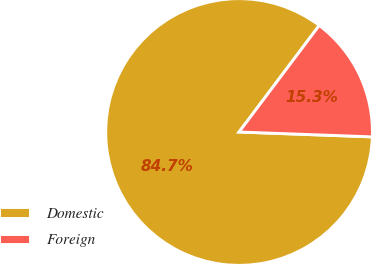Convert chart. <chart><loc_0><loc_0><loc_500><loc_500><pie_chart><fcel>Domestic<fcel>Foreign<nl><fcel>84.68%<fcel>15.32%<nl></chart> 